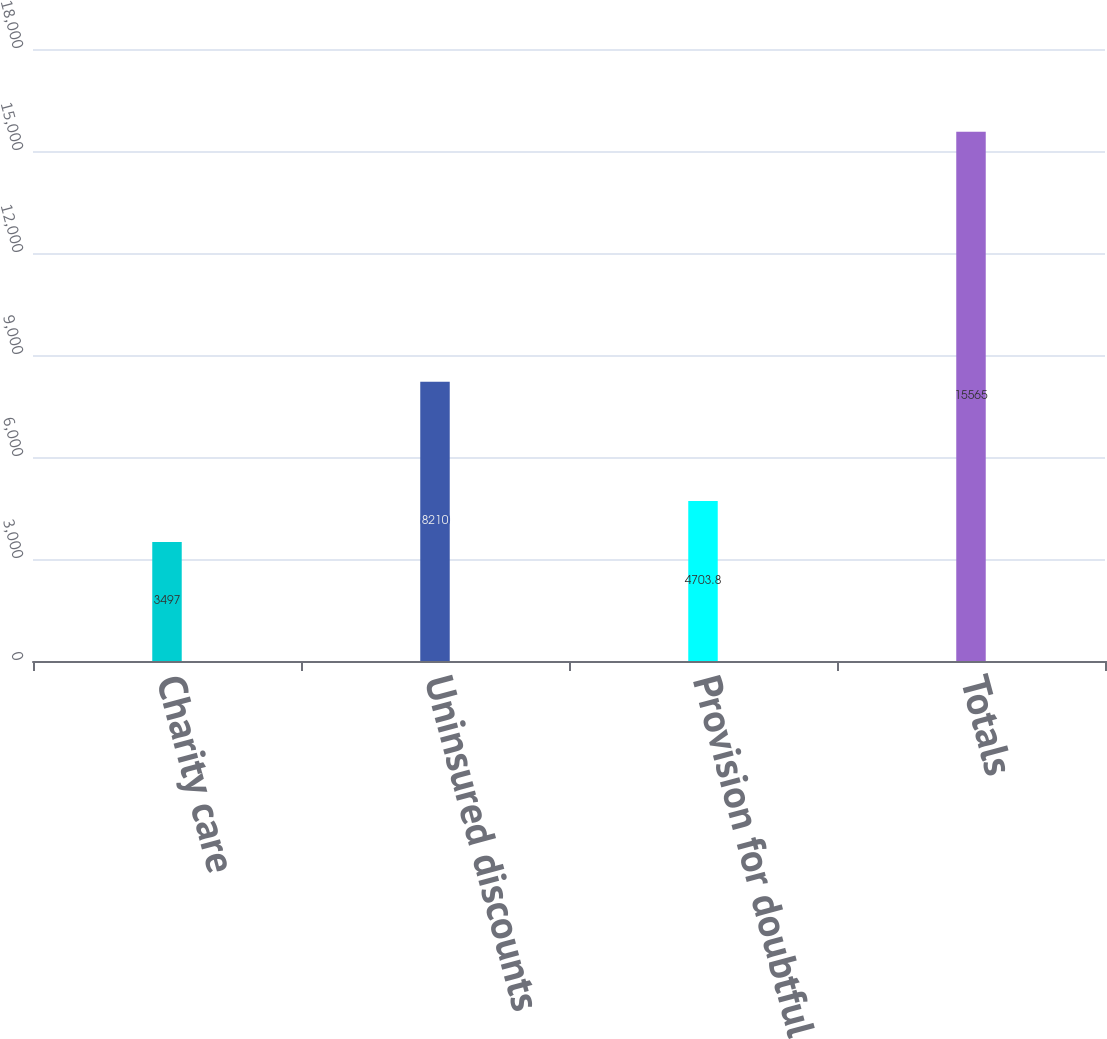<chart> <loc_0><loc_0><loc_500><loc_500><bar_chart><fcel>Charity care<fcel>Uninsured discounts<fcel>Provision for doubtful<fcel>Totals<nl><fcel>3497<fcel>8210<fcel>4703.8<fcel>15565<nl></chart> 